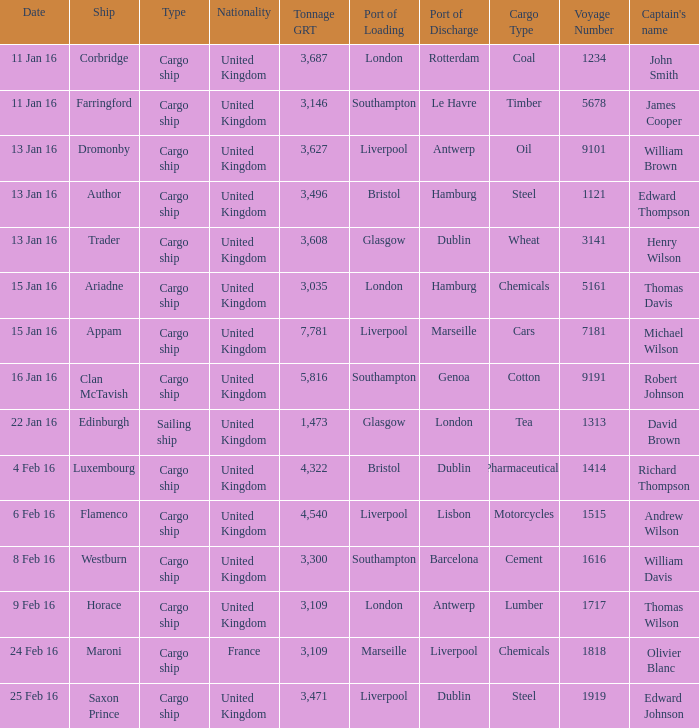Can you parse all the data within this table? {'header': ['Date', 'Ship', 'Type', 'Nationality', 'Tonnage GRT', 'Port of Loading', 'Port of Discharge', 'Cargo Type', 'Voyage Number', "Captain's name"], 'rows': [['11 Jan 16', 'Corbridge', 'Cargo ship', 'United Kingdom', '3,687', 'London', 'Rotterdam', 'Coal', '1234', 'John Smith'], ['11 Jan 16', 'Farringford', 'Cargo ship', 'United Kingdom', '3,146', 'Southampton', 'Le Havre', 'Timber', '5678', 'James Cooper'], ['13 Jan 16', 'Dromonby', 'Cargo ship', 'United Kingdom', '3,627', 'Liverpool', 'Antwerp', 'Oil', '9101', 'William Brown'], ['13 Jan 16', 'Author', 'Cargo ship', 'United Kingdom', '3,496', 'Bristol', 'Hamburg', 'Steel', '1121', 'Edward Thompson'], ['13 Jan 16', 'Trader', 'Cargo ship', 'United Kingdom', '3,608', 'Glasgow', 'Dublin', 'Wheat', '3141', 'Henry Wilson'], ['15 Jan 16', 'Ariadne', 'Cargo ship', 'United Kingdom', '3,035', 'London', 'Hamburg', 'Chemicals', '5161', 'Thomas Davis'], ['15 Jan 16', 'Appam', 'Cargo ship', 'United Kingdom', '7,781', 'Liverpool', 'Marseille', 'Cars', '7181', 'Michael Wilson'], ['16 Jan 16', 'Clan McTavish', 'Cargo ship', 'United Kingdom', '5,816', 'Southampton', 'Genoa', 'Cotton', '9191', 'Robert Johnson'], ['22 Jan 16', 'Edinburgh', 'Sailing ship', 'United Kingdom', '1,473', 'Glasgow', 'London', 'Tea', '1313', 'David Brown'], ['4 Feb 16', 'Luxembourg', 'Cargo ship', 'United Kingdom', '4,322', 'Bristol', 'Dublin', 'Pharmaceuticals', '1414', 'Richard Thompson'], ['6 Feb 16', 'Flamenco', 'Cargo ship', 'United Kingdom', '4,540', 'Liverpool', 'Lisbon', 'Motorcycles', '1515', 'Andrew Wilson'], ['8 Feb 16', 'Westburn', 'Cargo ship', 'United Kingdom', '3,300', 'Southampton', 'Barcelona', 'Cement', '1616', 'William Davis'], ['9 Feb 16', 'Horace', 'Cargo ship', 'United Kingdom', '3,109', 'London', 'Antwerp', 'Lumber', '1717', 'Thomas Wilson'], ['24 Feb 16', 'Maroni', 'Cargo ship', 'France', '3,109', 'Marseille', 'Liverpool', 'Chemicals', '1818', 'Olivier Blanc'], ['25 Feb 16', 'Saxon Prince', 'Cargo ship', 'United Kingdom', '3,471', 'Liverpool', 'Dublin', 'Steel', '1919', 'Edward Johnson']]} What is the most tonnage grt of any ship sunk or captured on 16 jan 16? 5816.0. 